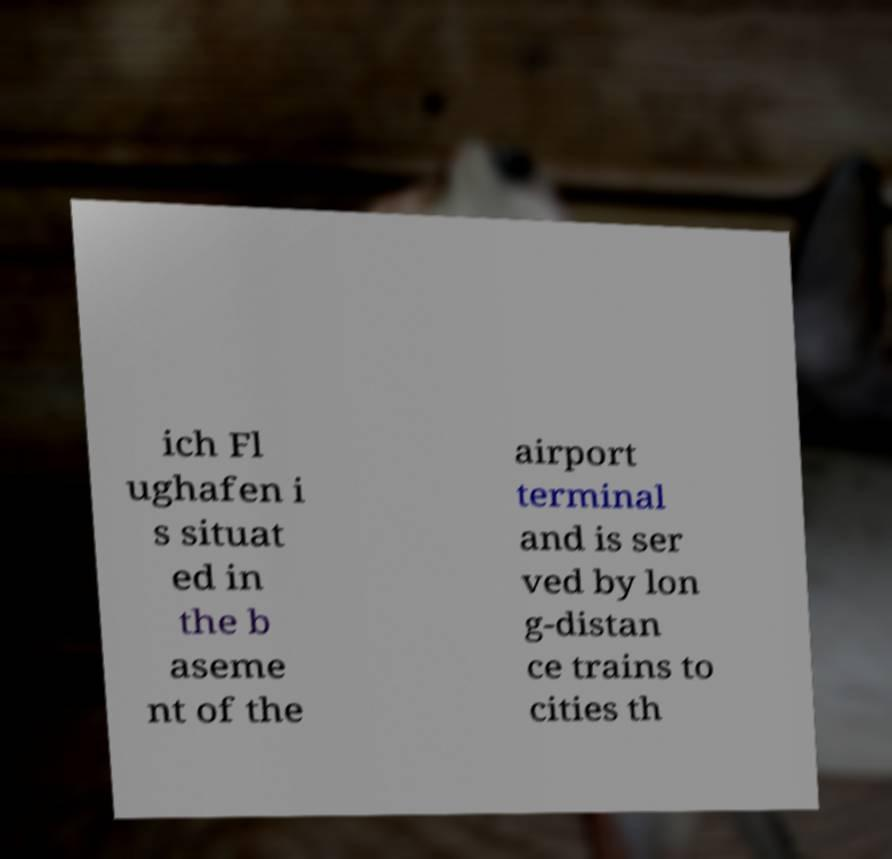For documentation purposes, I need the text within this image transcribed. Could you provide that? ich Fl ughafen i s situat ed in the b aseme nt of the airport terminal and is ser ved by lon g-distan ce trains to cities th 